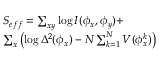Convert formula to latex. <formula><loc_0><loc_0><loc_500><loc_500>\begin{array} { l } { { S _ { e f f } = \sum _ { x y } \log I ( \phi _ { x } , \phi _ { y } ) + } } \\ { { \sum _ { x } \left ( \log \Delta ^ { 2 } ( \phi _ { x } ) - N \sum _ { k = 1 } ^ { N } V ( \phi _ { x } ^ { k } ) \right ) } } \end{array}</formula> 